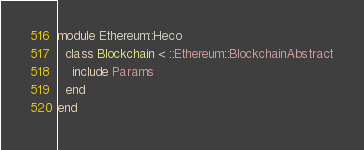Convert code to text. <code><loc_0><loc_0><loc_500><loc_500><_Ruby_>module Ethereum::Heco
  class Blockchain < ::Ethereum::BlockchainAbstract
    include Params
  end
end
</code> 